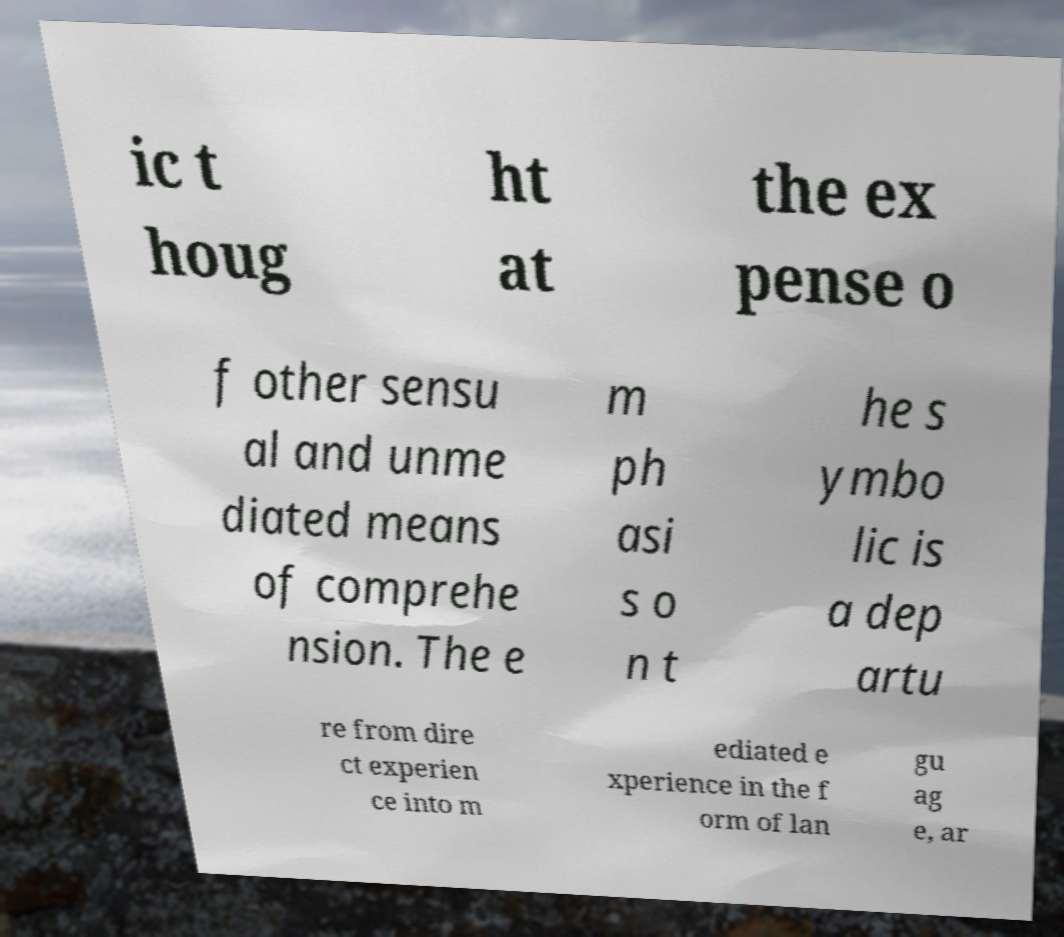What messages or text are displayed in this image? I need them in a readable, typed format. ic t houg ht at the ex pense o f other sensu al and unme diated means of comprehe nsion. The e m ph asi s o n t he s ymbo lic is a dep artu re from dire ct experien ce into m ediated e xperience in the f orm of lan gu ag e, ar 